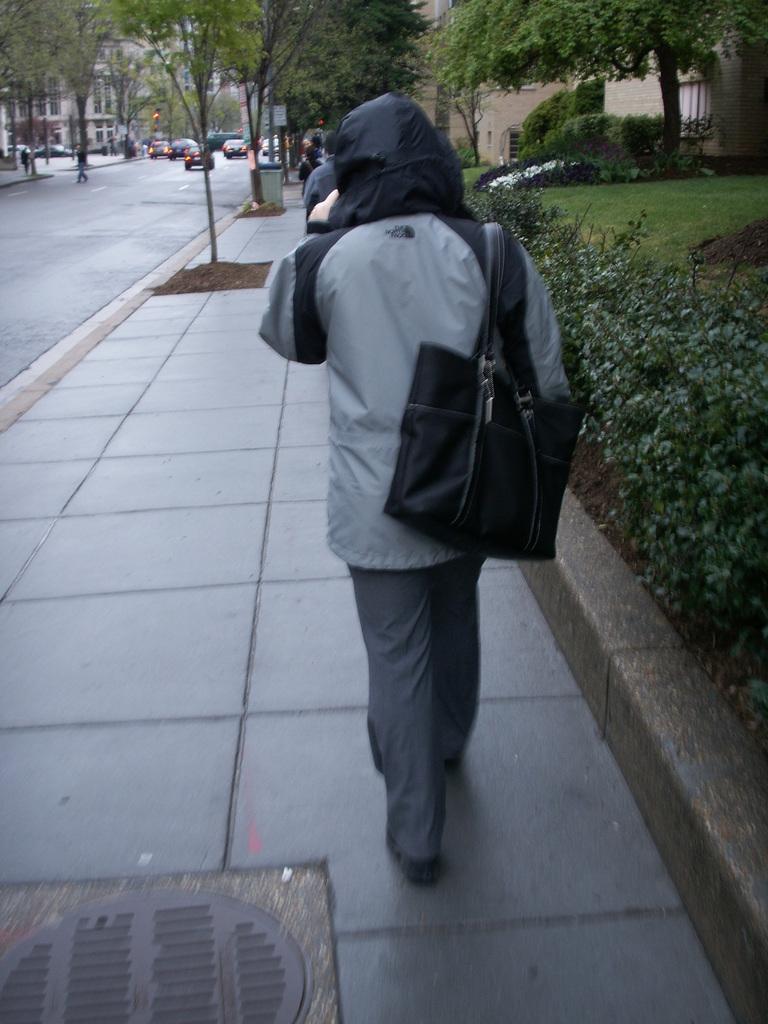In one or two sentences, can you explain what this image depicts? In this image I can see a person wearing a handbag. At the back side there are trees cars and a building. 